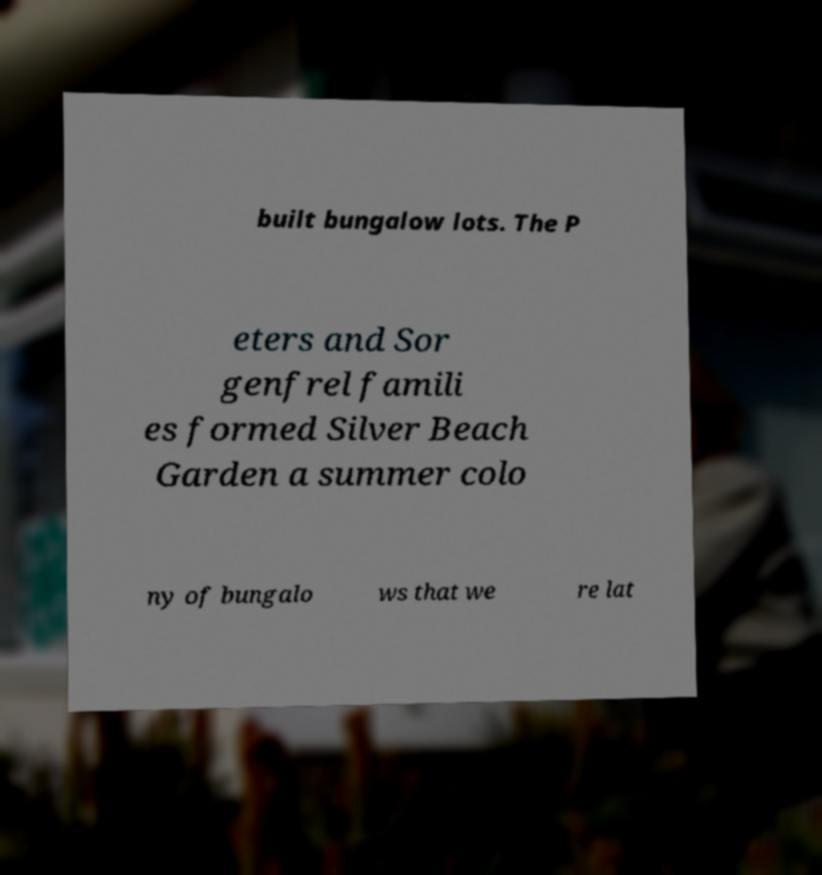I need the written content from this picture converted into text. Can you do that? built bungalow lots. The P eters and Sor genfrel famili es formed Silver Beach Garden a summer colo ny of bungalo ws that we re lat 